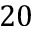Convert formula to latex. <formula><loc_0><loc_0><loc_500><loc_500>2 0</formula> 